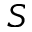Convert formula to latex. <formula><loc_0><loc_0><loc_500><loc_500>S</formula> 